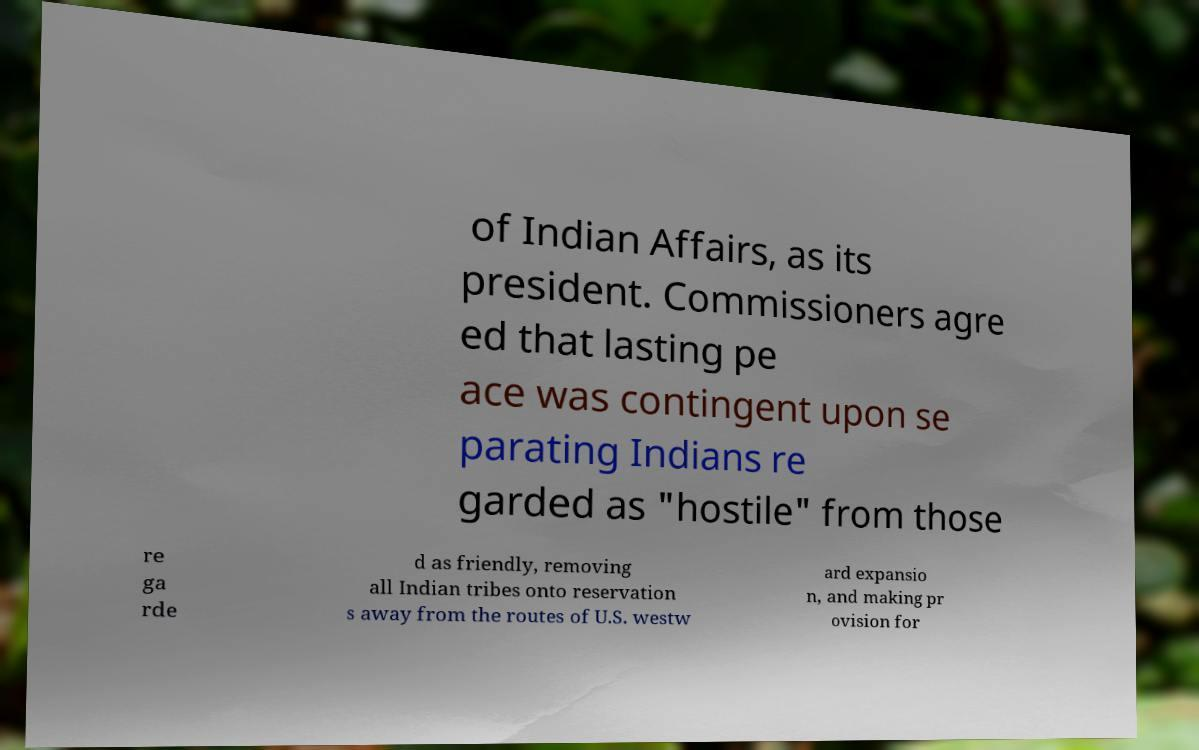Could you extract and type out the text from this image? of Indian Affairs, as its president. Commissioners agre ed that lasting pe ace was contingent upon se parating Indians re garded as "hostile" from those re ga rde d as friendly, removing all Indian tribes onto reservation s away from the routes of U.S. westw ard expansio n, and making pr ovision for 